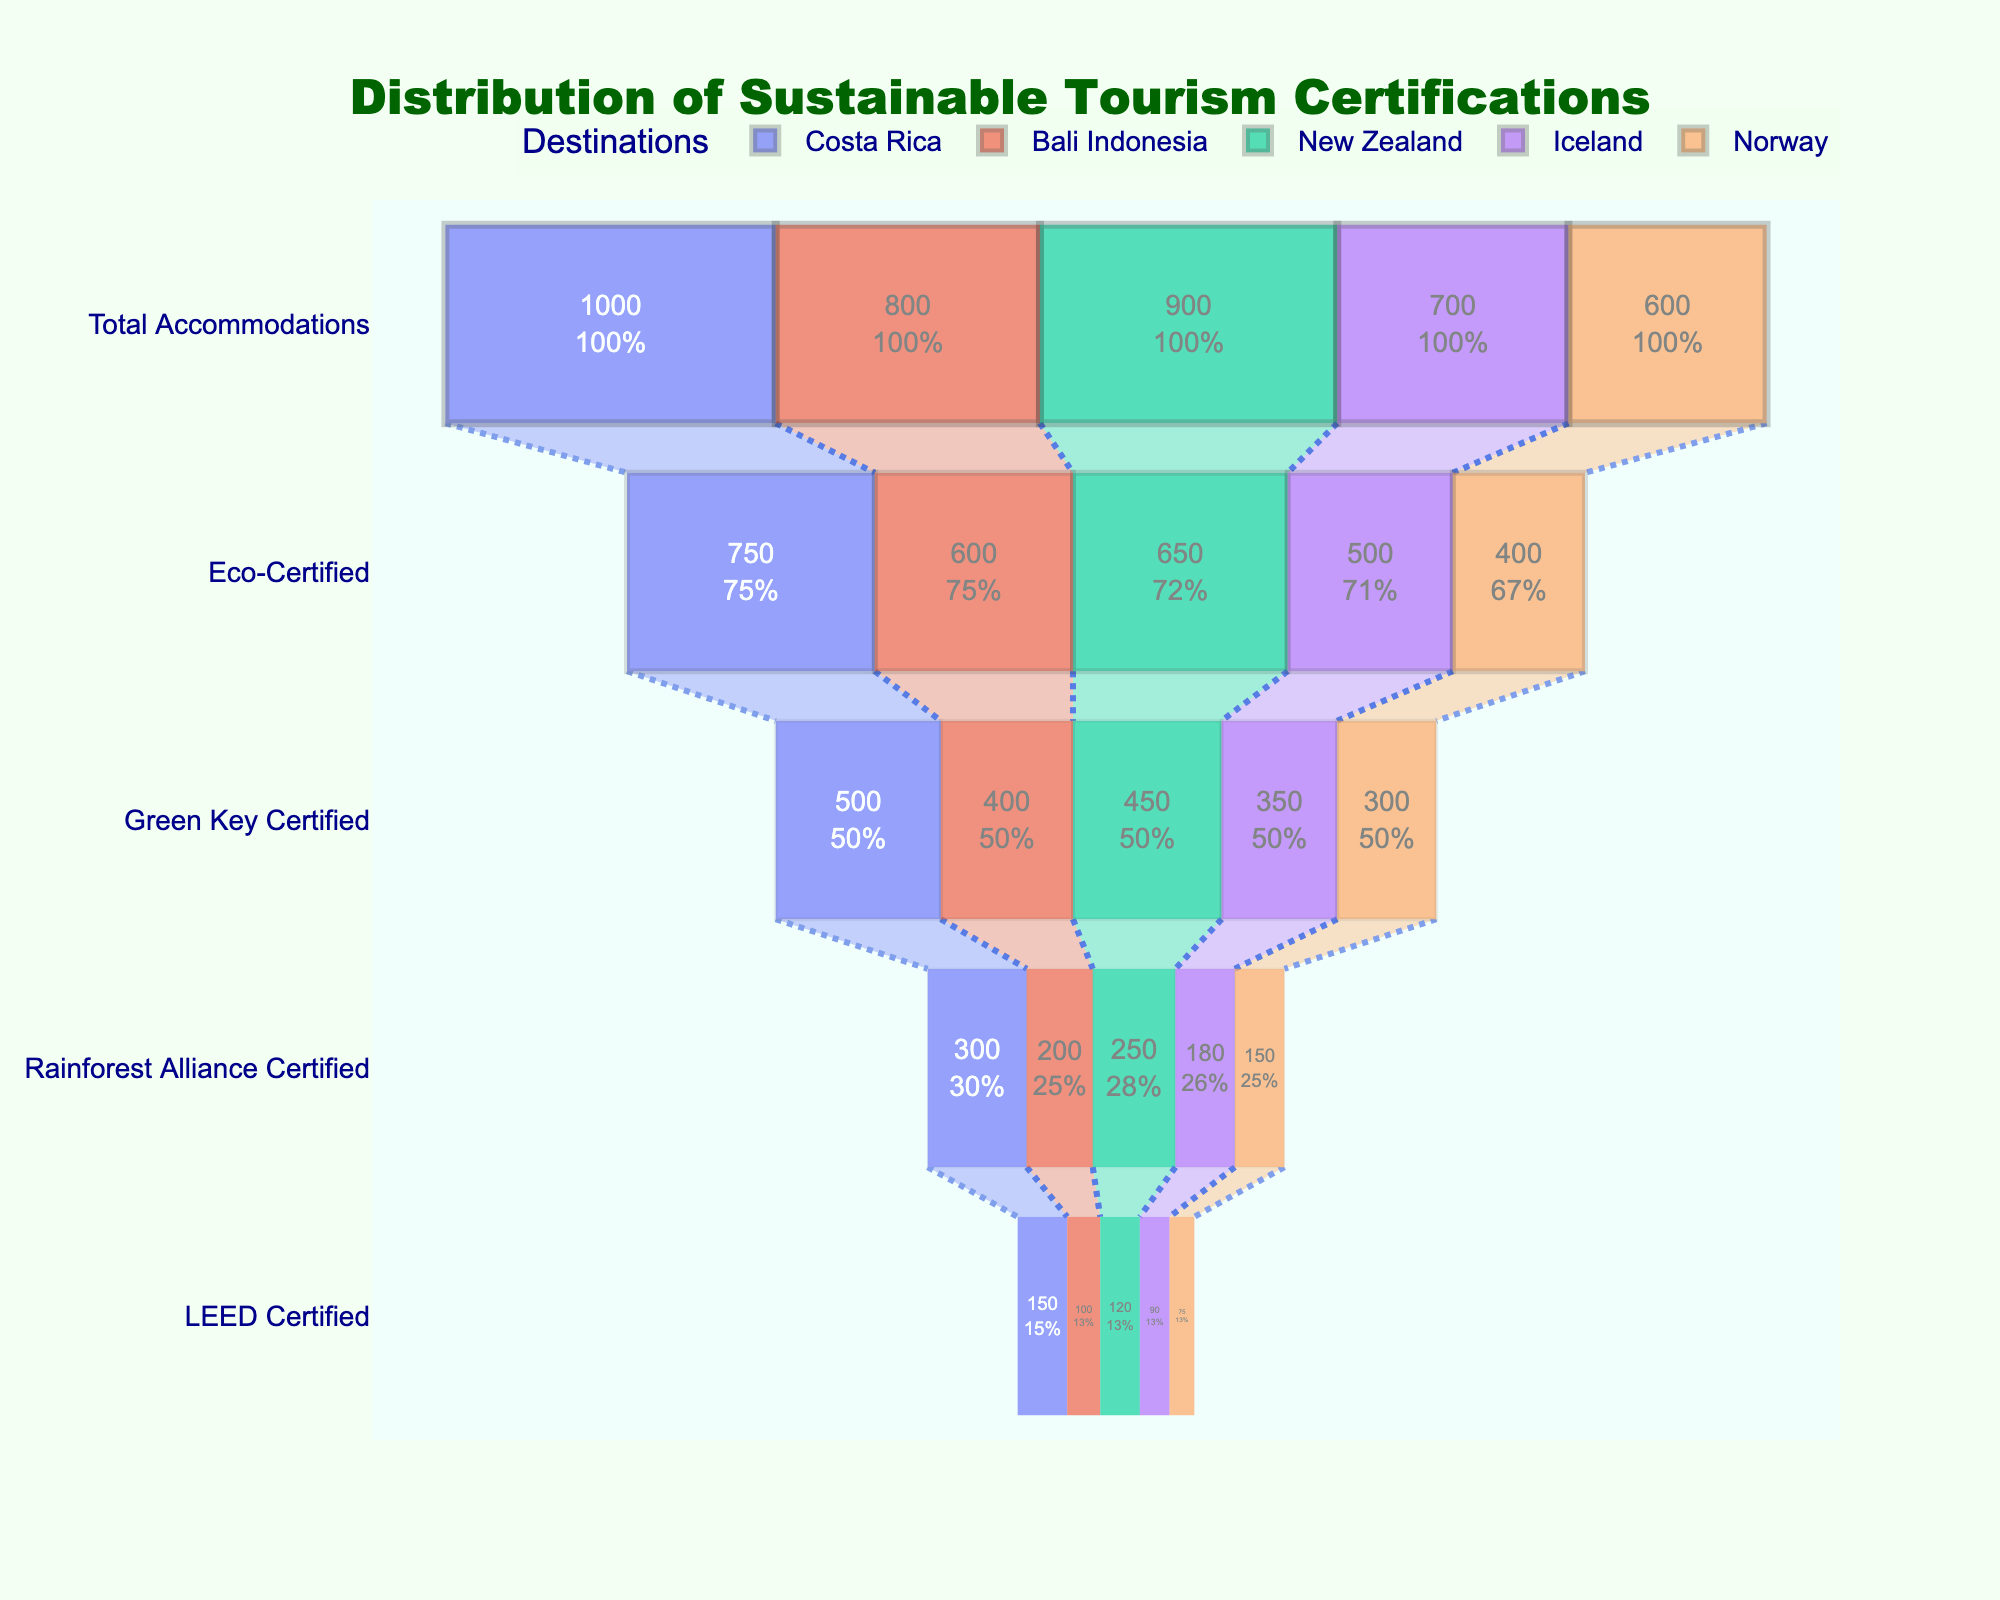What is the title of the chart? The title is usually found at the top of the chart and provides a summary of what the chart represents. Here, it reads "Distribution of Sustainable Tourism Certifications".
Answer: Distribution of Sustainable Tourism Certifications Which destination has the highest number of Eco-Certified accommodations? By looking at the funnel sections labeled "Eco-Certified" (the first section after "Total Accommodations"), the destination with the highest number is Costa Rica with 750 accommodations.
Answer: Costa Rica How many total accommodations are listed for New Zealand? The number of total accommodations is shown at the widest part of the funnel for New Zealand. It is 900.
Answer: 900 What is the percentage of Green Key Certified accommodations in Iceland relative to its total accommodations? The Green Key Certified accommodations for Iceland is 350. To find the percentage, divide 350 by the total accommodations for Iceland (700) and multiply by 100. (350 / 700) * 100 = 50%.
Answer: 50% Compare the number of LEED Certified accommodations between Bali Indonesia and Norway. Which has more? LEED Certified accommodations can be found at the narrowest part of the funnel for each destination. Bali Indonesia has 100 LEED Certified accommodations, while Norway has 75. Bali Indonesia has more.
Answer: Bali Indonesia How many more Eco-Certified accommodations does Costa Rica have compared to Norway? Costa Rica has 750 Eco-Certified accommodations and Norway has 400. Subtract Norway's count from Costa Rica's: 750 - 400 = 350.
Answer: 350 What percentage of accommodations in Costa Rica are Rainforest Alliance Certified? Rainforest Alliance Certified accommodations for Costa Rica is 300. Divide this by the total accommodations (1000) and multiply by 100. (300 / 1000) * 100 = 30%.
Answer: 30% Which destination has the lowest number of Green Key Certified accommodations? By comparing the Green Key Certified values for all destinations, Norway has the lowest with 300 accommodations.
Answer: Norway Which certification category shows the highest variability among destinations? By visually comparing the height differences between the bars of each certification category, Eco-Certified shows the highest variability with counts ranging from 750 (Costa Rica) to 400 (Norway).
Answer: Eco-Certified If you sum the LEED Certified accommodations across all destinations, what is the total? Add the LEED Certified accommodations for all destinations: 150 (Costa Rica) + 100 (Bali Indonesia) + 120 (New Zealand) + 90 (Iceland) + 75 (Norway) = 535.
Answer: 535 